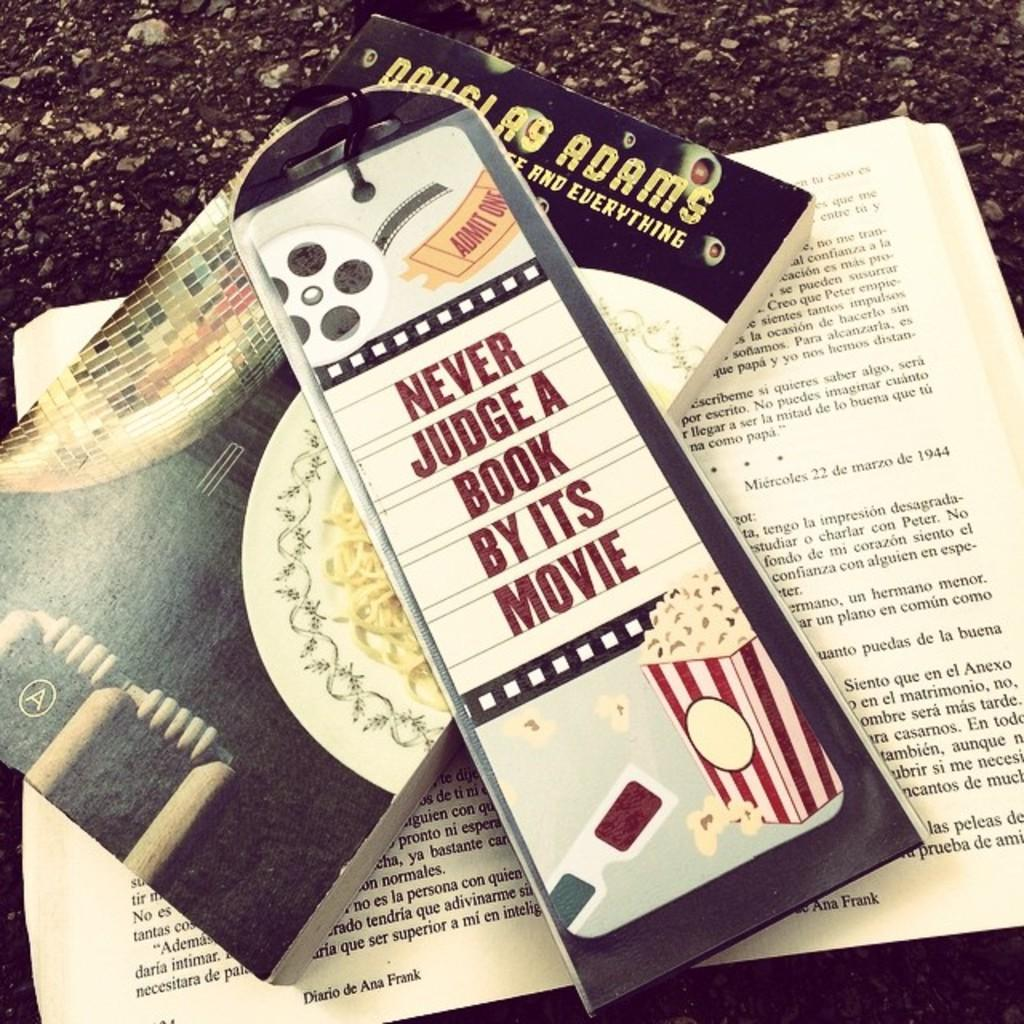<image>
Render a clear and concise summary of the photo. A bookmark that reads never judge a book by its movie and a book underneath. 